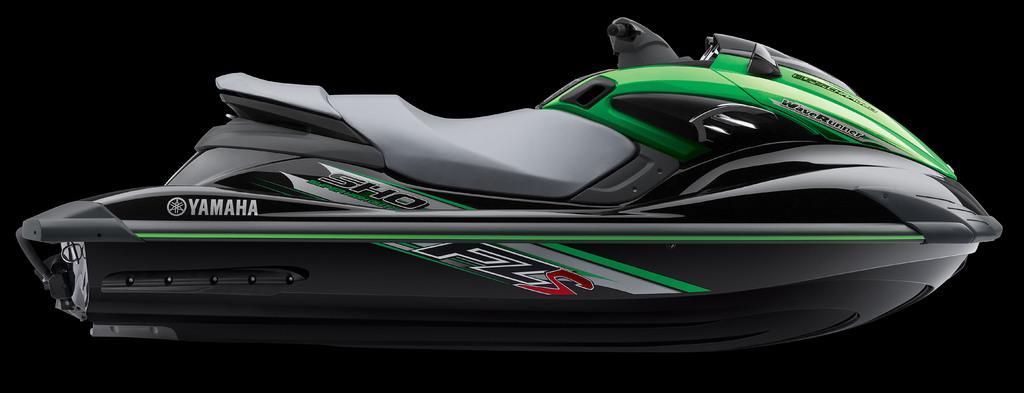Please provide a concise description of this image. In this image we can see jet ski. 